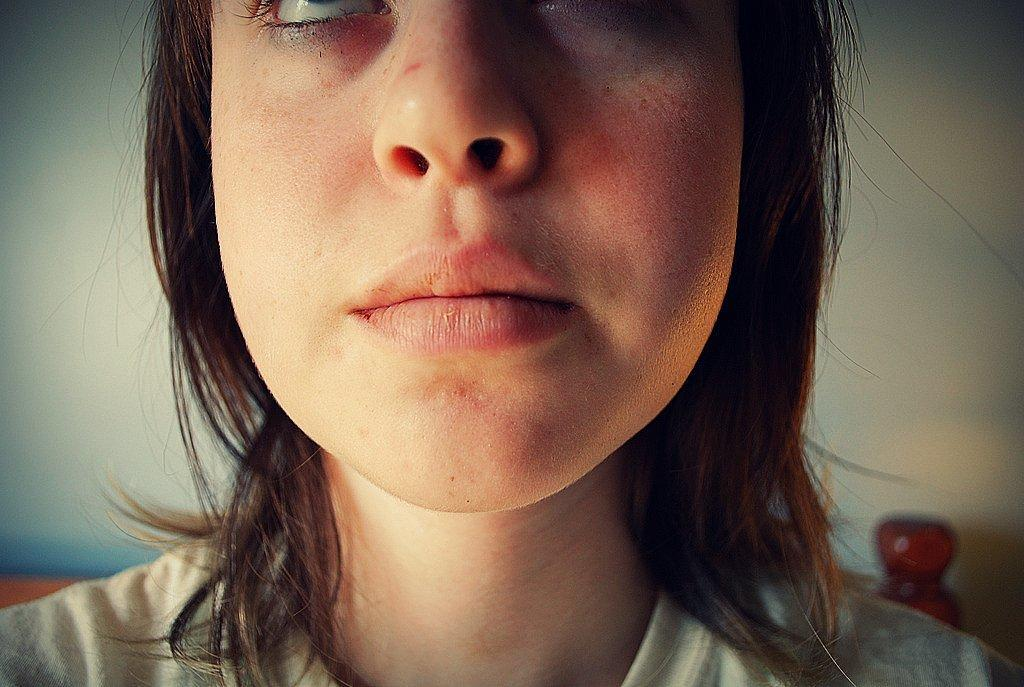What is the main subject of the image? The main subject of the image is a woman. Can you describe the background of the image? There is a wall visible in the background of the image. What is the price of the coat the woman is wearing in the image? There is no coat visible in the image, and therefore no price can be determined. 